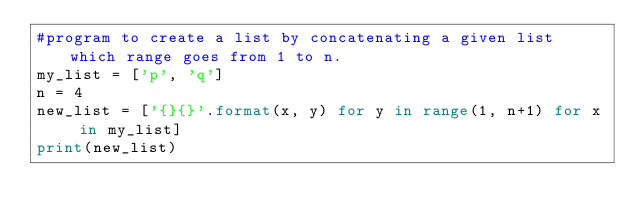<code> <loc_0><loc_0><loc_500><loc_500><_Python_>#program to create a list by concatenating a given list which range goes from 1 to n.
my_list = ['p', 'q']
n = 4
new_list = ['{}{}'.format(x, y) for y in range(1, n+1) for x in my_list]
print(new_list)</code> 